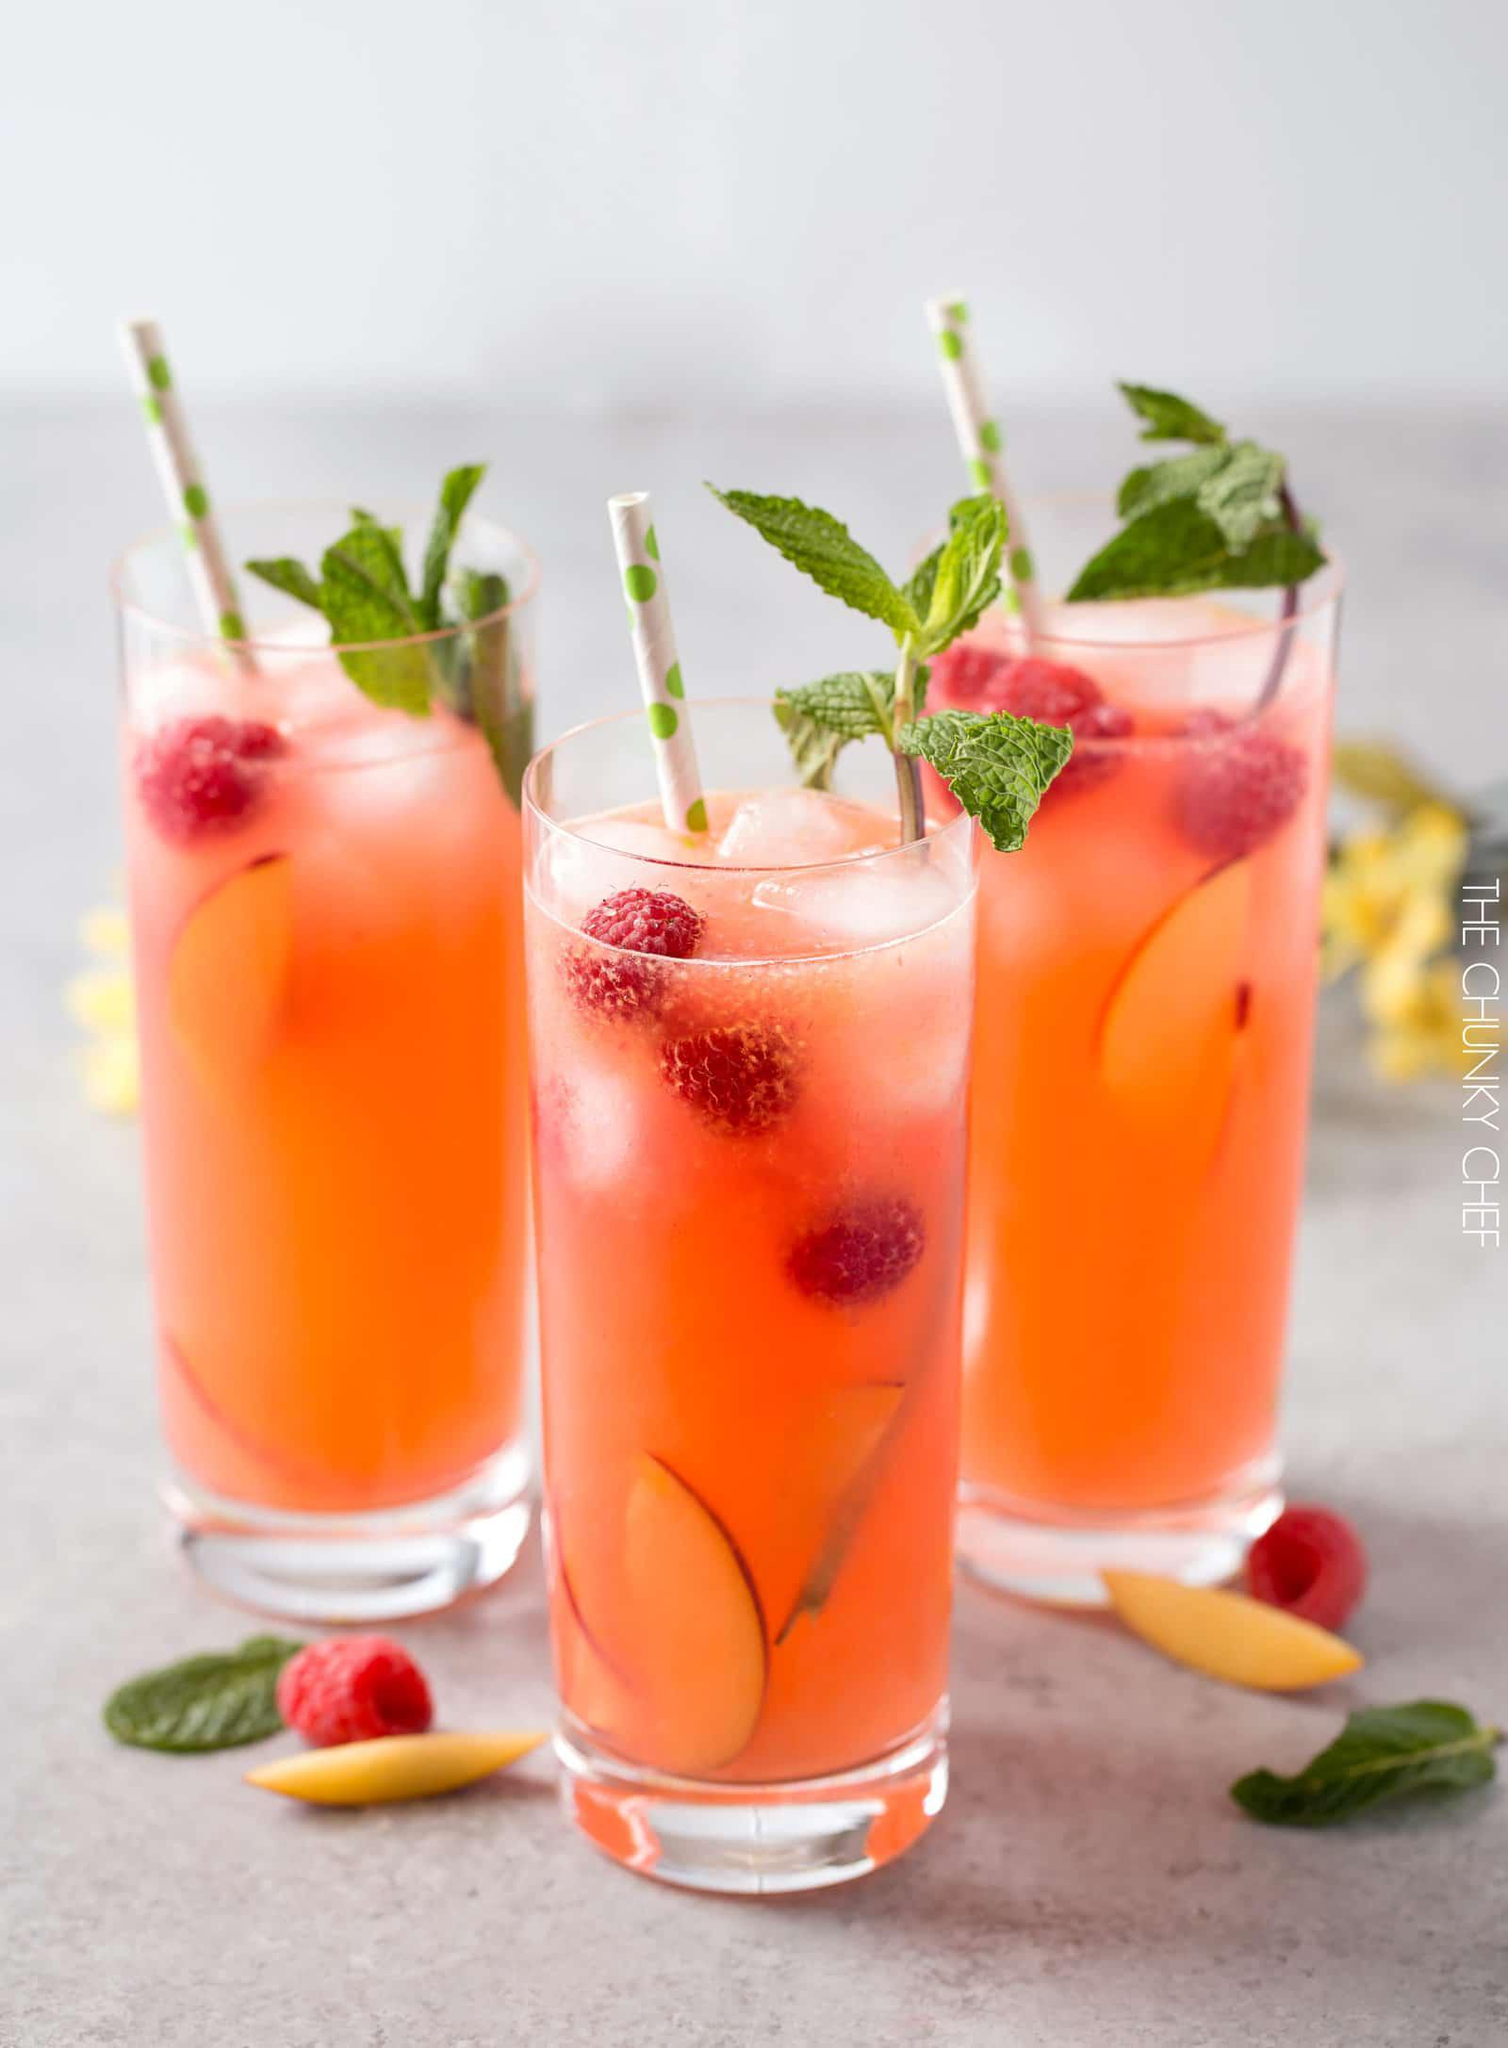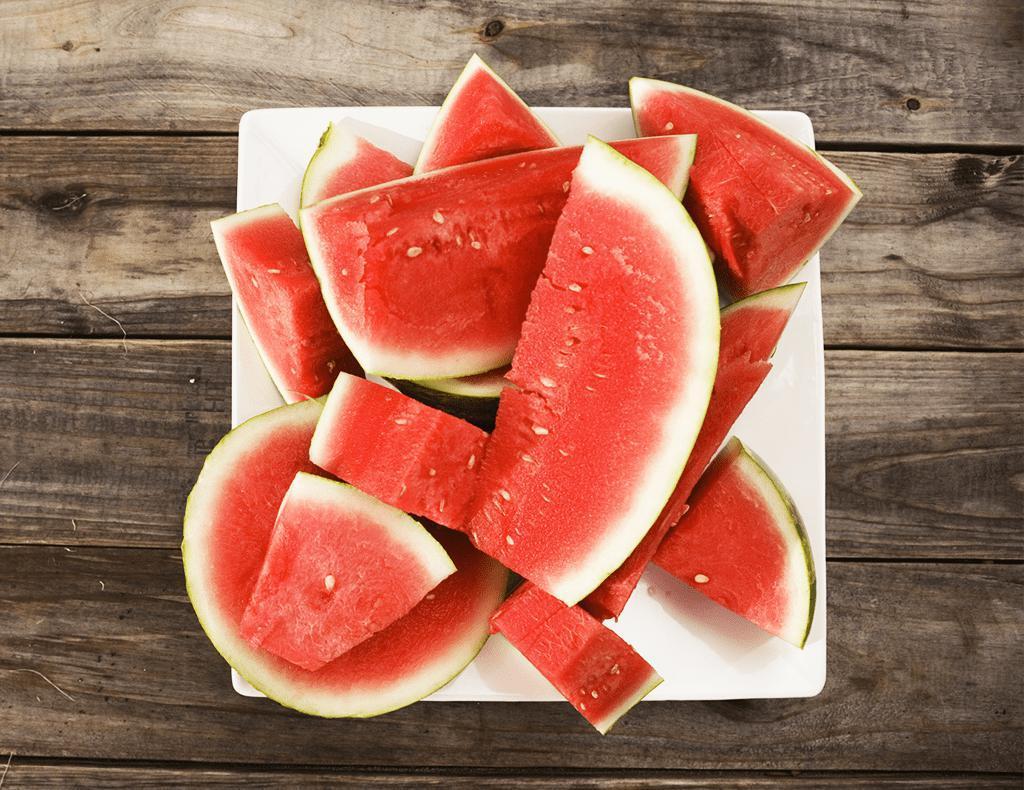The first image is the image on the left, the second image is the image on the right. Given the left and right images, does the statement "In one image, one or more fruit drinks is garnished with raspberries, lemon and mint, and has a straw extended from the top, while a second image shows cut watermelon." hold true? Answer yes or no. Yes. The first image is the image on the left, the second image is the image on the right. For the images displayed, is the sentence "There is exactly one straw in a drink." factually correct? Answer yes or no. No. 